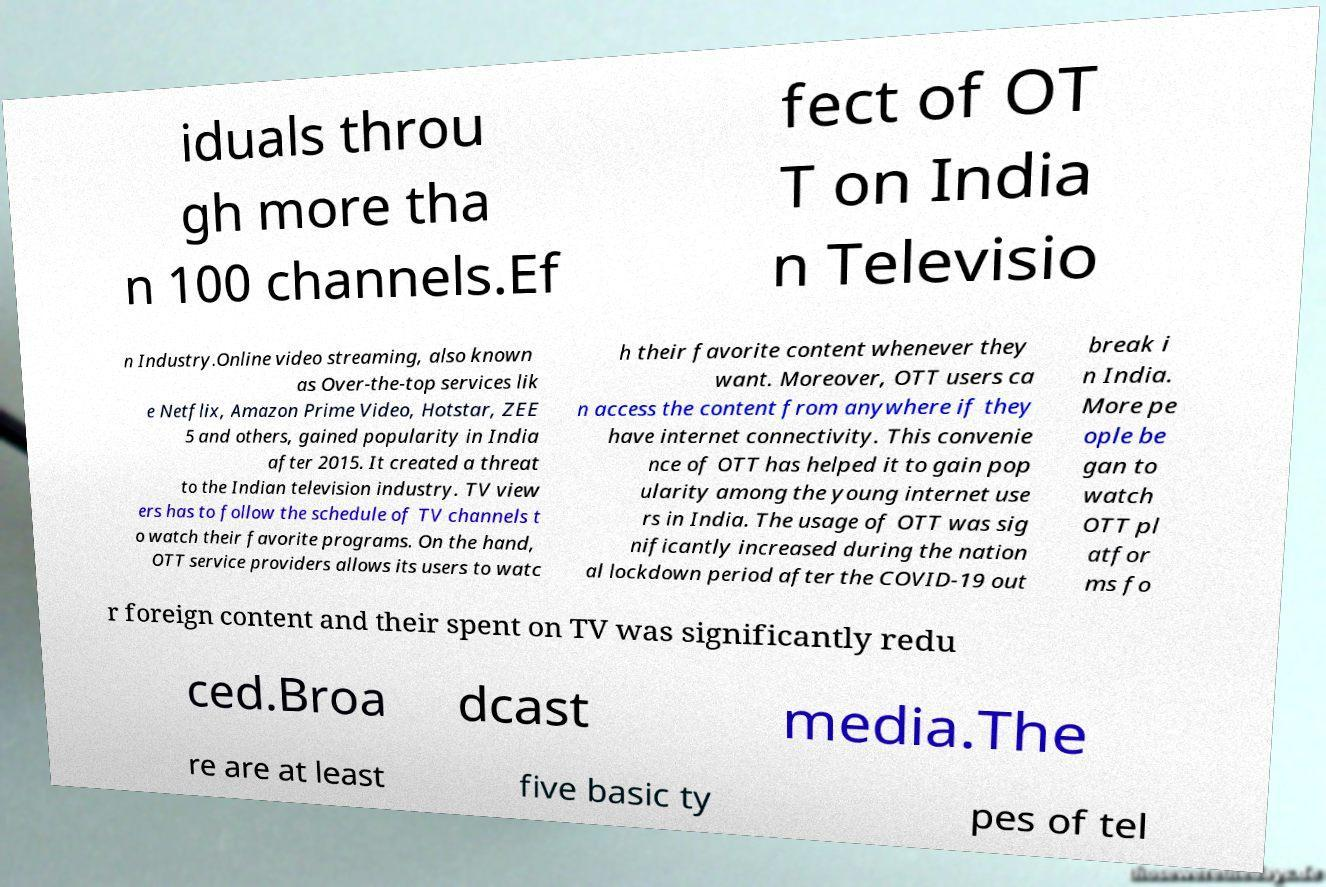Can you read and provide the text displayed in the image?This photo seems to have some interesting text. Can you extract and type it out for me? iduals throu gh more tha n 100 channels.Ef fect of OT T on India n Televisio n Industry.Online video streaming, also known as Over-the-top services lik e Netflix, Amazon Prime Video, Hotstar, ZEE 5 and others, gained popularity in India after 2015. It created a threat to the Indian television industry. TV view ers has to follow the schedule of TV channels t o watch their favorite programs. On the hand, OTT service providers allows its users to watc h their favorite content whenever they want. Moreover, OTT users ca n access the content from anywhere if they have internet connectivity. This convenie nce of OTT has helped it to gain pop ularity among the young internet use rs in India. The usage of OTT was sig nificantly increased during the nation al lockdown period after the COVID-19 out break i n India. More pe ople be gan to watch OTT pl atfor ms fo r foreign content and their spent on TV was significantly redu ced.Broa dcast media.The re are at least five basic ty pes of tel 